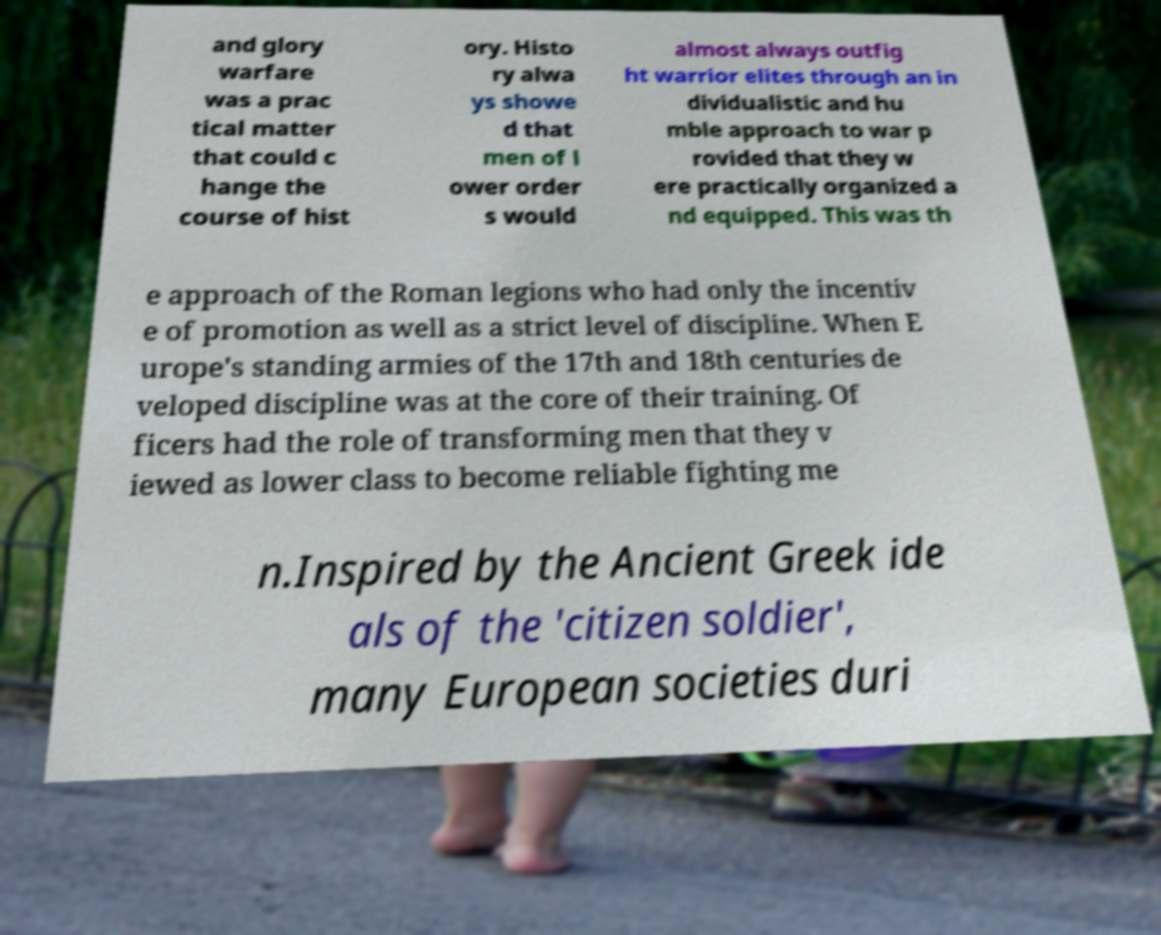What messages or text are displayed in this image? I need them in a readable, typed format. and glory warfare was a prac tical matter that could c hange the course of hist ory. Histo ry alwa ys showe d that men of l ower order s would almost always outfig ht warrior elites through an in dividualistic and hu mble approach to war p rovided that they w ere practically organized a nd equipped. This was th e approach of the Roman legions who had only the incentiv e of promotion as well as a strict level of discipline. When E urope's standing armies of the 17th and 18th centuries de veloped discipline was at the core of their training. Of ficers had the role of transforming men that they v iewed as lower class to become reliable fighting me n.Inspired by the Ancient Greek ide als of the 'citizen soldier', many European societies duri 